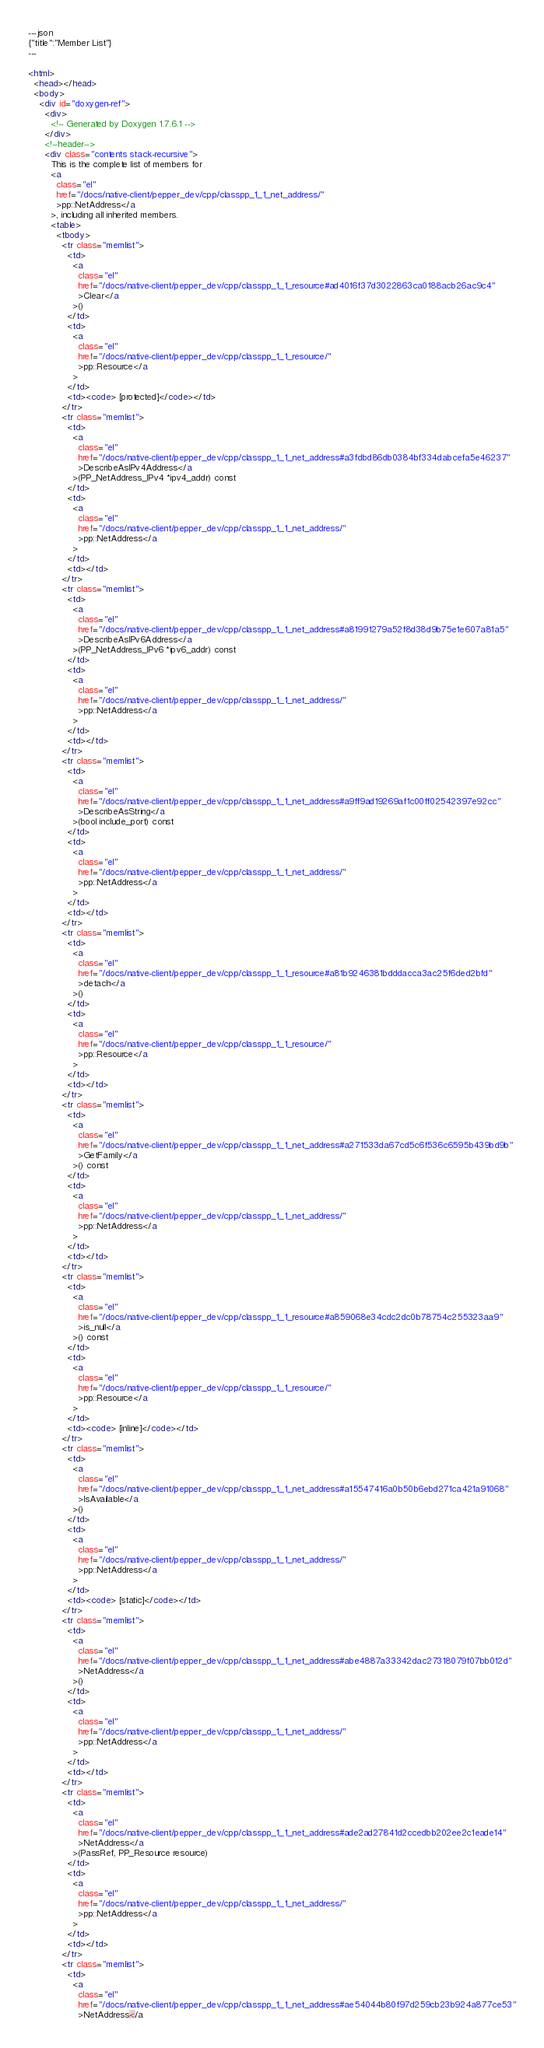Convert code to text. <code><loc_0><loc_0><loc_500><loc_500><_HTML_>---json
{"title":"Member List"}
---

<html>
  <head></head>
  <body>
    <div id="doxygen-ref">
      <div>
        <!-- Generated by Doxygen 1.7.6.1 -->
      </div>
      <!--header-->
      <div class="contents stack-recursive">
        This is the complete list of members for
        <a
          class="el"
          href="/docs/native-client/pepper_dev/cpp/classpp_1_1_net_address/"
          >pp::NetAddress</a
        >, including all inherited members.
        <table>
          <tbody>
            <tr class="memlist">
              <td>
                <a
                  class="el"
                  href="/docs/native-client/pepper_dev/cpp/classpp_1_1_resource#ad4016f37d3022863ca0188acb26ac9c4"
                  >Clear</a
                >()
              </td>
              <td>
                <a
                  class="el"
                  href="/docs/native-client/pepper_dev/cpp/classpp_1_1_resource/"
                  >pp::Resource</a
                >
              </td>
              <td><code> [protected]</code></td>
            </tr>
            <tr class="memlist">
              <td>
                <a
                  class="el"
                  href="/docs/native-client/pepper_dev/cpp/classpp_1_1_net_address#a3fdbd86db0384bf334dabcefa5e46237"
                  >DescribeAsIPv4Address</a
                >(PP_NetAddress_IPv4 *ipv4_addr) const
              </td>
              <td>
                <a
                  class="el"
                  href="/docs/native-client/pepper_dev/cpp/classpp_1_1_net_address/"
                  >pp::NetAddress</a
                >
              </td>
              <td></td>
            </tr>
            <tr class="memlist">
              <td>
                <a
                  class="el"
                  href="/docs/native-client/pepper_dev/cpp/classpp_1_1_net_address#a81991279a52f8d38d9b75e1e607a81a5"
                  >DescribeAsIPv6Address</a
                >(PP_NetAddress_IPv6 *ipv6_addr) const
              </td>
              <td>
                <a
                  class="el"
                  href="/docs/native-client/pepper_dev/cpp/classpp_1_1_net_address/"
                  >pp::NetAddress</a
                >
              </td>
              <td></td>
            </tr>
            <tr class="memlist">
              <td>
                <a
                  class="el"
                  href="/docs/native-client/pepper_dev/cpp/classpp_1_1_net_address#a9ff9ad19269af1c00ff02542397e92cc"
                  >DescribeAsString</a
                >(bool include_port) const
              </td>
              <td>
                <a
                  class="el"
                  href="/docs/native-client/pepper_dev/cpp/classpp_1_1_net_address/"
                  >pp::NetAddress</a
                >
              </td>
              <td></td>
            </tr>
            <tr class="memlist">
              <td>
                <a
                  class="el"
                  href="/docs/native-client/pepper_dev/cpp/classpp_1_1_resource#a81b9246381bdddacca3ac25f6ded2bfd"
                  >detach</a
                >()
              </td>
              <td>
                <a
                  class="el"
                  href="/docs/native-client/pepper_dev/cpp/classpp_1_1_resource/"
                  >pp::Resource</a
                >
              </td>
              <td></td>
            </tr>
            <tr class="memlist">
              <td>
                <a
                  class="el"
                  href="/docs/native-client/pepper_dev/cpp/classpp_1_1_net_address#a271533da67cd5c6f536c6595b439bd9b"
                  >GetFamily</a
                >() const
              </td>
              <td>
                <a
                  class="el"
                  href="/docs/native-client/pepper_dev/cpp/classpp_1_1_net_address/"
                  >pp::NetAddress</a
                >
              </td>
              <td></td>
            </tr>
            <tr class="memlist">
              <td>
                <a
                  class="el"
                  href="/docs/native-client/pepper_dev/cpp/classpp_1_1_resource#a859068e34cdc2dc0b78754c255323aa9"
                  >is_null</a
                >() const
              </td>
              <td>
                <a
                  class="el"
                  href="/docs/native-client/pepper_dev/cpp/classpp_1_1_resource/"
                  >pp::Resource</a
                >
              </td>
              <td><code> [inline]</code></td>
            </tr>
            <tr class="memlist">
              <td>
                <a
                  class="el"
                  href="/docs/native-client/pepper_dev/cpp/classpp_1_1_net_address#a15547416a0b50b6ebd271ca421a91068"
                  >IsAvailable</a
                >()
              </td>
              <td>
                <a
                  class="el"
                  href="/docs/native-client/pepper_dev/cpp/classpp_1_1_net_address/"
                  >pp::NetAddress</a
                >
              </td>
              <td><code> [static]</code></td>
            </tr>
            <tr class="memlist">
              <td>
                <a
                  class="el"
                  href="/docs/native-client/pepper_dev/cpp/classpp_1_1_net_address#abe4887a33342dac27318079f07bb012d"
                  >NetAddress</a
                >()
              </td>
              <td>
                <a
                  class="el"
                  href="/docs/native-client/pepper_dev/cpp/classpp_1_1_net_address/"
                  >pp::NetAddress</a
                >
              </td>
              <td></td>
            </tr>
            <tr class="memlist">
              <td>
                <a
                  class="el"
                  href="/docs/native-client/pepper_dev/cpp/classpp_1_1_net_address#ade2ad27841d2ccedbb202ee2c1eade14"
                  >NetAddress</a
                >(PassRef, PP_Resource resource)
              </td>
              <td>
                <a
                  class="el"
                  href="/docs/native-client/pepper_dev/cpp/classpp_1_1_net_address/"
                  >pp::NetAddress</a
                >
              </td>
              <td></td>
            </tr>
            <tr class="memlist">
              <td>
                <a
                  class="el"
                  href="/docs/native-client/pepper_dev/cpp/classpp_1_1_net_address#ae54044b80f97d259cb23b924a877ce53"
                  >NetAddress</a</code> 